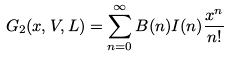Convert formula to latex. <formula><loc_0><loc_0><loc_500><loc_500>G _ { 2 } ( x , V , L ) = \sum _ { n = 0 } ^ { \infty } B ( n ) I ( n ) \frac { x ^ { n } } { n ! }</formula> 